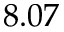Convert formula to latex. <formula><loc_0><loc_0><loc_500><loc_500>8 . 0 7</formula> 